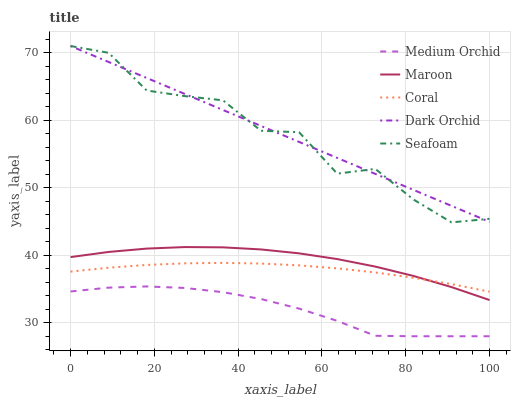Does Medium Orchid have the minimum area under the curve?
Answer yes or no. Yes. Does Dark Orchid have the maximum area under the curve?
Answer yes or no. Yes. Does Dark Orchid have the minimum area under the curve?
Answer yes or no. No. Does Medium Orchid have the maximum area under the curve?
Answer yes or no. No. Is Dark Orchid the smoothest?
Answer yes or no. Yes. Is Seafoam the roughest?
Answer yes or no. Yes. Is Medium Orchid the smoothest?
Answer yes or no. No. Is Medium Orchid the roughest?
Answer yes or no. No. Does Medium Orchid have the lowest value?
Answer yes or no. Yes. Does Dark Orchid have the lowest value?
Answer yes or no. No. Does Seafoam have the highest value?
Answer yes or no. Yes. Does Medium Orchid have the highest value?
Answer yes or no. No. Is Maroon less than Dark Orchid?
Answer yes or no. Yes. Is Maroon greater than Medium Orchid?
Answer yes or no. Yes. Does Maroon intersect Coral?
Answer yes or no. Yes. Is Maroon less than Coral?
Answer yes or no. No. Is Maroon greater than Coral?
Answer yes or no. No. Does Maroon intersect Dark Orchid?
Answer yes or no. No. 